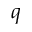<formula> <loc_0><loc_0><loc_500><loc_500>q</formula> 